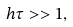Convert formula to latex. <formula><loc_0><loc_0><loc_500><loc_500>h \tau > > 1 ,</formula> 